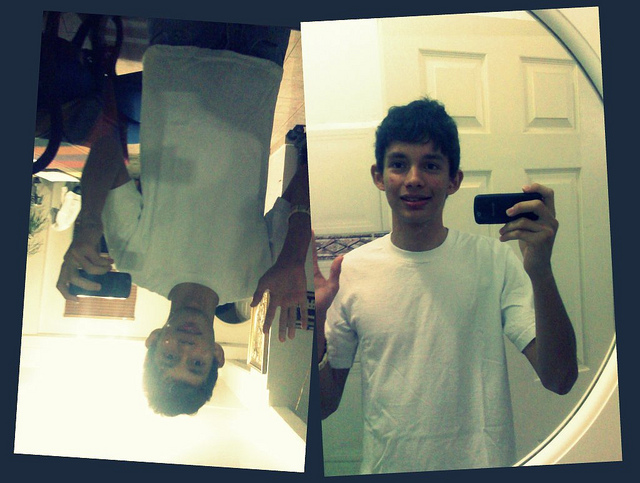What can you infer about the setting of the image from the objects and the overall scene? From the objects and the overall scene, it appears that the setting is a personal, indoor space, possibly a bedroom. The plain white door in the background suggests a residential environment, and the casual attire of the person indicates they are likely at home, in a comfortable and relaxed atmosphere. This setting is typically where one might engage in taking selfies or experimenting with reflections, as seen in the image. 